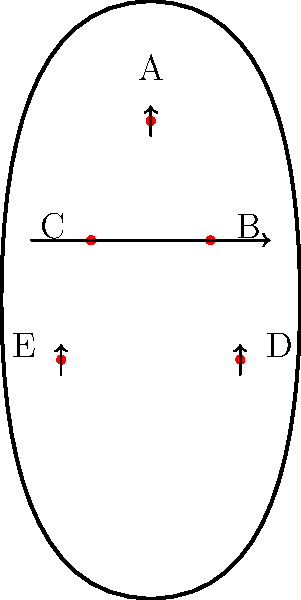In the diagram above, which pressure points are most likely targeted during a seated forward bend (Paschimottanasana) for lower back injury recovery? Select all that apply. To answer this question, let's analyze the pressure points and the nature of a seated forward bend (Paschimottanasana):

1. Point A: Located at the base of the skull. This point is not typically targeted in a seated forward bend.

2. Points B and C: Located in the mid-back region. These points are engaged during a forward bend as the back muscles stretch.

3. Points D and E: Located in the lower back/hip area. These points are primary targets in a seated forward bend, especially for lower back injury recovery.

Paschimottanasana involves:
- Sitting with legs extended forward
- Bending from the hips
- Reaching towards the toes

This pose primarily stretches:
- Lower back muscles
- Hamstrings
- Spinal extensors

For lower back injury recovery, the focus is on gently stretching and strengthening the lower back region. Therefore, the pressure points most targeted during this pose for lower back recovery are D and E.

Points B and C may also experience some stretch, but they are not the primary focus for lower back injury recovery in this pose.
Answer: D and E 